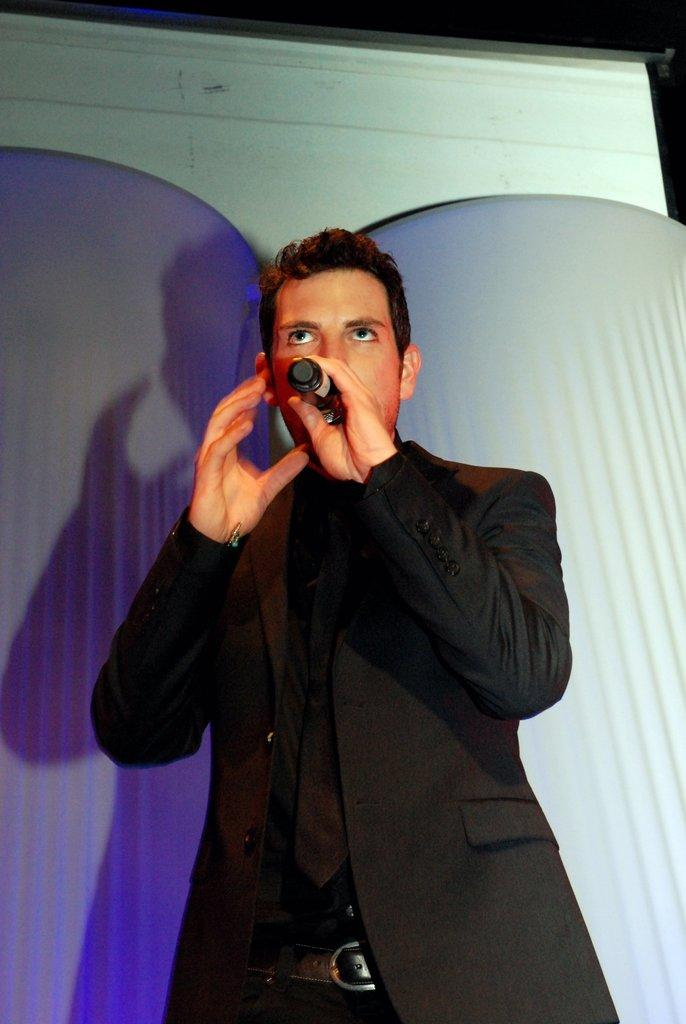Who is the main subject in the image? There is a man in the image. What is the man doing in the image? The man is standing and appears to be speaking. What object is the man holding in the image? The man is holding a microphone in the image. What is the stranger's reaction to the man's speech in the image? There is no stranger present in the image, so it is not possible to determine their reaction to the man's speech. 